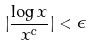<formula> <loc_0><loc_0><loc_500><loc_500>| \frac { \log x } { x ^ { c } } | < \epsilon</formula> 